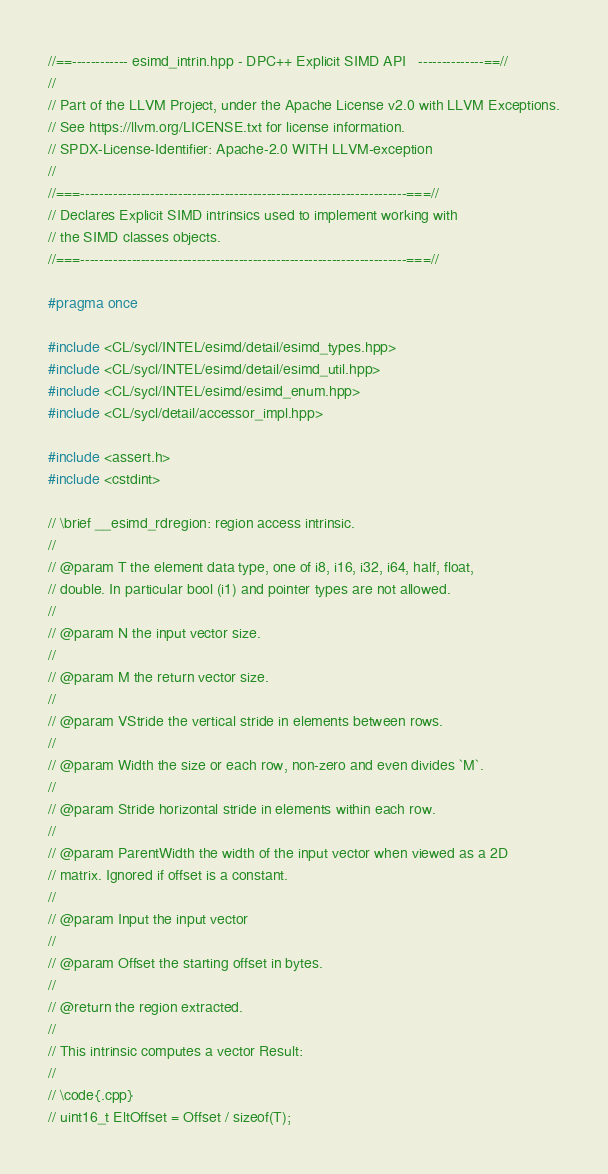<code> <loc_0><loc_0><loc_500><loc_500><_C++_>//==------------ esimd_intrin.hpp - DPC++ Explicit SIMD API   --------------==//
//
// Part of the LLVM Project, under the Apache License v2.0 with LLVM Exceptions.
// See https://llvm.org/LICENSE.txt for license information.
// SPDX-License-Identifier: Apache-2.0 WITH LLVM-exception
//
//===----------------------------------------------------------------------===//
// Declares Explicit SIMD intrinsics used to implement working with
// the SIMD classes objects.
//===----------------------------------------------------------------------===//

#pragma once

#include <CL/sycl/INTEL/esimd/detail/esimd_types.hpp>
#include <CL/sycl/INTEL/esimd/detail/esimd_util.hpp>
#include <CL/sycl/INTEL/esimd/esimd_enum.hpp>
#include <CL/sycl/detail/accessor_impl.hpp>

#include <assert.h>
#include <cstdint>

// \brief __esimd_rdregion: region access intrinsic.
//
// @param T the element data type, one of i8, i16, i32, i64, half, float,
// double. In particular bool (i1) and pointer types are not allowed.
//
// @param N the input vector size.
//
// @param M the return vector size.
//
// @param VStride the vertical stride in elements between rows.
//
// @param Width the size or each row, non-zero and even divides `M`.
//
// @param Stride horizontal stride in elements within each row.
//
// @param ParentWidth the width of the input vector when viewed as a 2D
// matrix. Ignored if offset is a constant.
//
// @param Input the input vector
//
// @param Offset the starting offset in bytes.
//
// @return the region extracted.
//
// This intrinsic computes a vector Result:
//
// \code{.cpp}
// uint16_t EltOffset = Offset / sizeof(T);</code> 